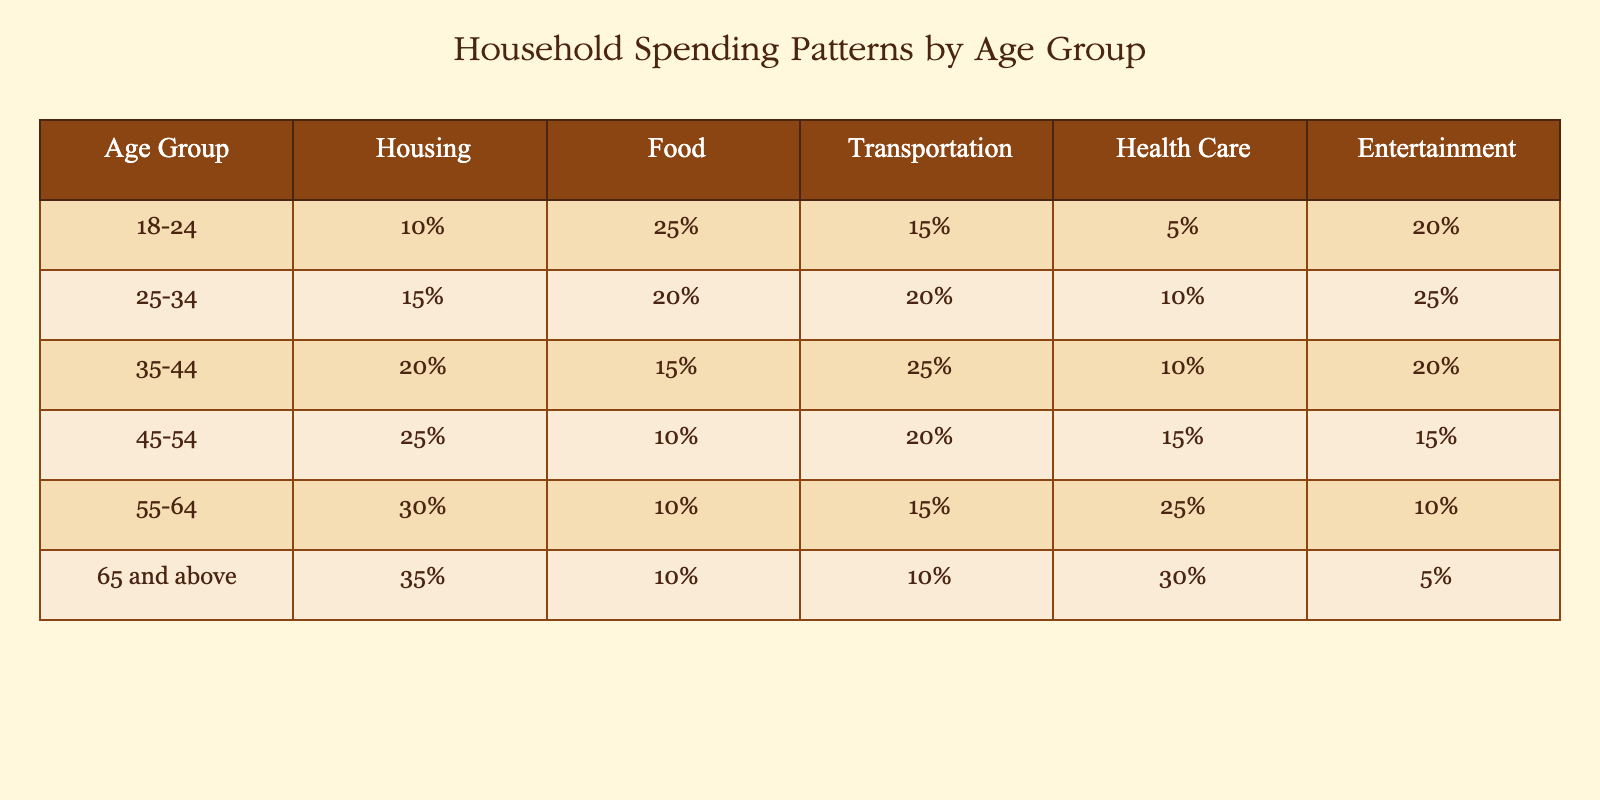What percentage of the 55-64 age group spending is on Housing? According to the table, the 55-64 age group's spending on Housing is 30%.
Answer: 30% Which age group spends the least on Entertainment? By examining the table, the age group 65 and above spends 5% on Entertainment, which is the least among all age groups.
Answer: 65 and above What is the difference in Healthcare spending between the 35-44 and 45-54 age groups? The Healthcare spending for 35-44 age group is 10%, and for the 45-54 age group, it is 15%. The difference is 15% - 10% = 5%.
Answer: 5% Is it true that the 25-34 age group spends more on Food than the 45-54 age group? The table shows that the 25-34 age group spends 20% on Food, while the 45-54 age group spends only 10%. Thus, it is true that 25-34 spends more.
Answer: Yes What is the total spending percentage for Housing across all age groups? To find the total, we sum all Housing spending percentages: 10% + 15% + 20% + 25% + 30% + 35% = 135%.
Answer: 135% Which age group has the highest percentage of Transportation spending? By looking at the table, the 35-44 age group spends the highest at 25% on Transportation.
Answer: 35-44 What is the average percentage spent on Health Care by the age groups 18-24, 35-44, and 55-64? For these age groups, the spending on Health Care is 5%, 10%, and 25%. The average is (5% + 10% + 25%)/3 = 40%/3 = 13.33%.
Answer: 13.33% Does the 45-54 age group spend more on Housing or Health Care? The 45-54 age group spends 25% on Housing and 15% on Health Care. Thus, they spend more on Housing.
Answer: Yes Which age group spends the most percentage on Food? Reviewing the table, the age group 18-24 spends the most on Food at 25%.
Answer: 18-24 